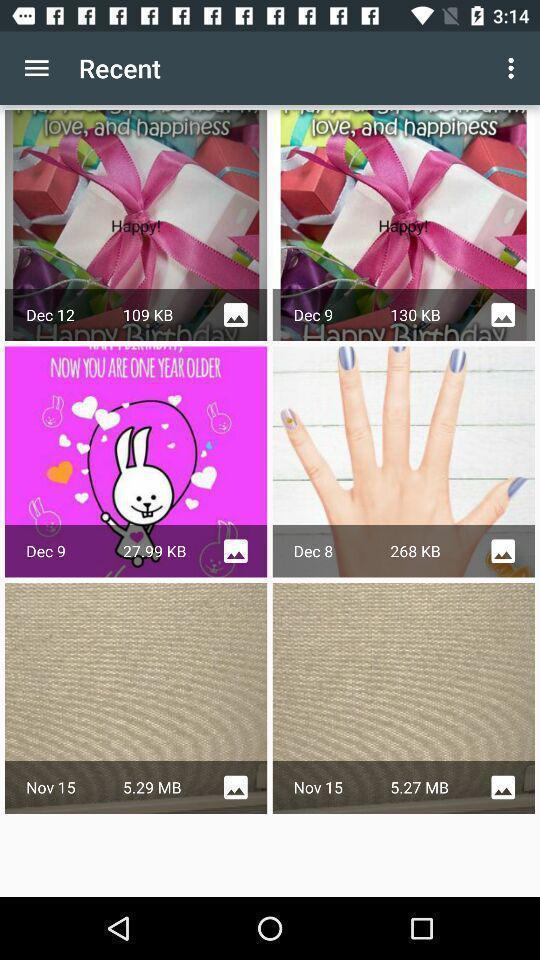What is the overall content of this screenshot? Screen displaying multiple images in a gallery. 